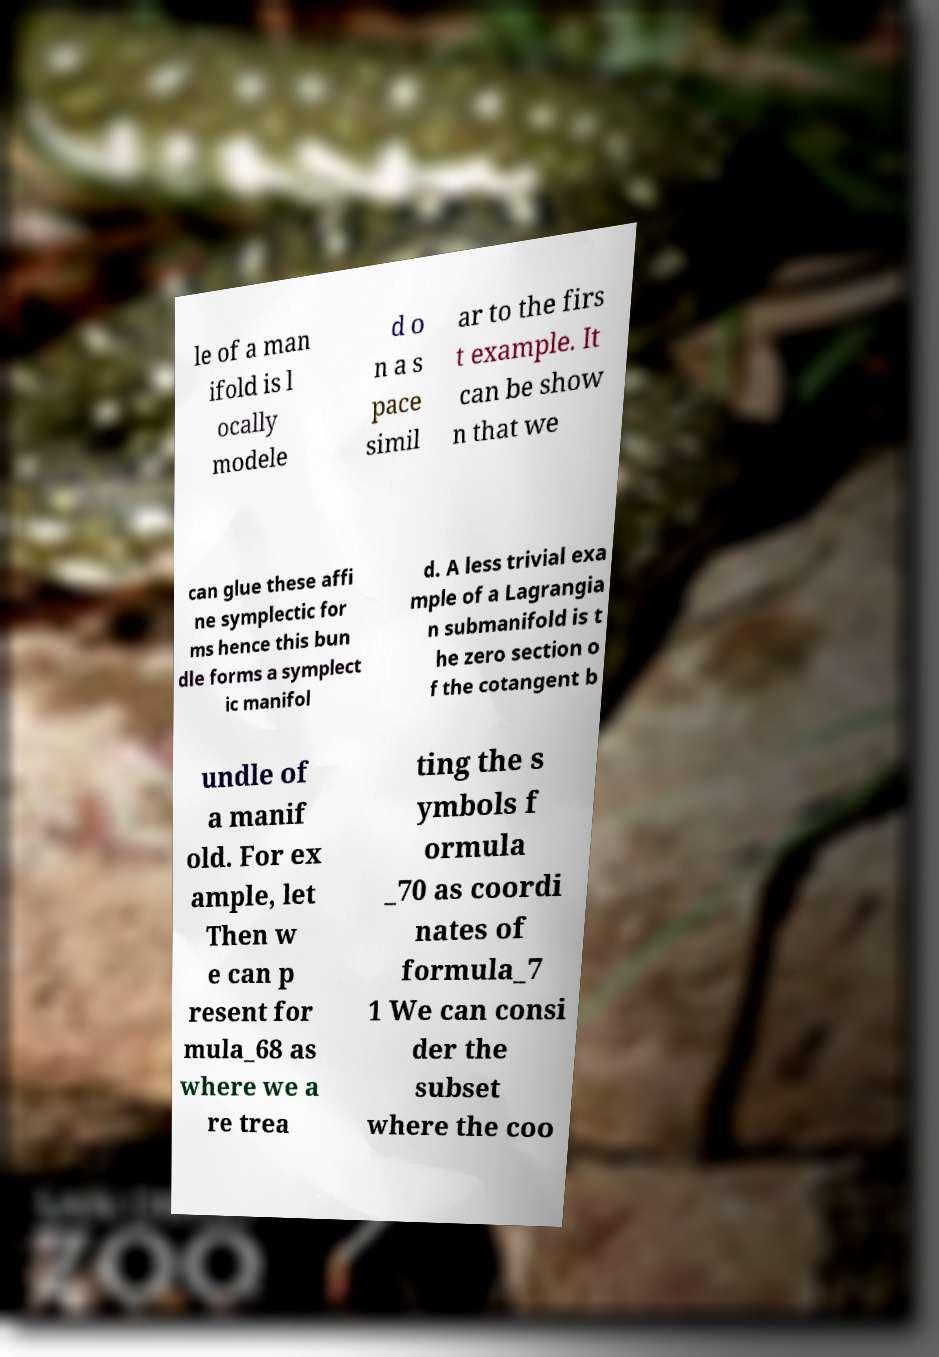Can you accurately transcribe the text from the provided image for me? le of a man ifold is l ocally modele d o n a s pace simil ar to the firs t example. It can be show n that we can glue these affi ne symplectic for ms hence this bun dle forms a symplect ic manifol d. A less trivial exa mple of a Lagrangia n submanifold is t he zero section o f the cotangent b undle of a manif old. For ex ample, let Then w e can p resent for mula_68 as where we a re trea ting the s ymbols f ormula _70 as coordi nates of formula_7 1 We can consi der the subset where the coo 